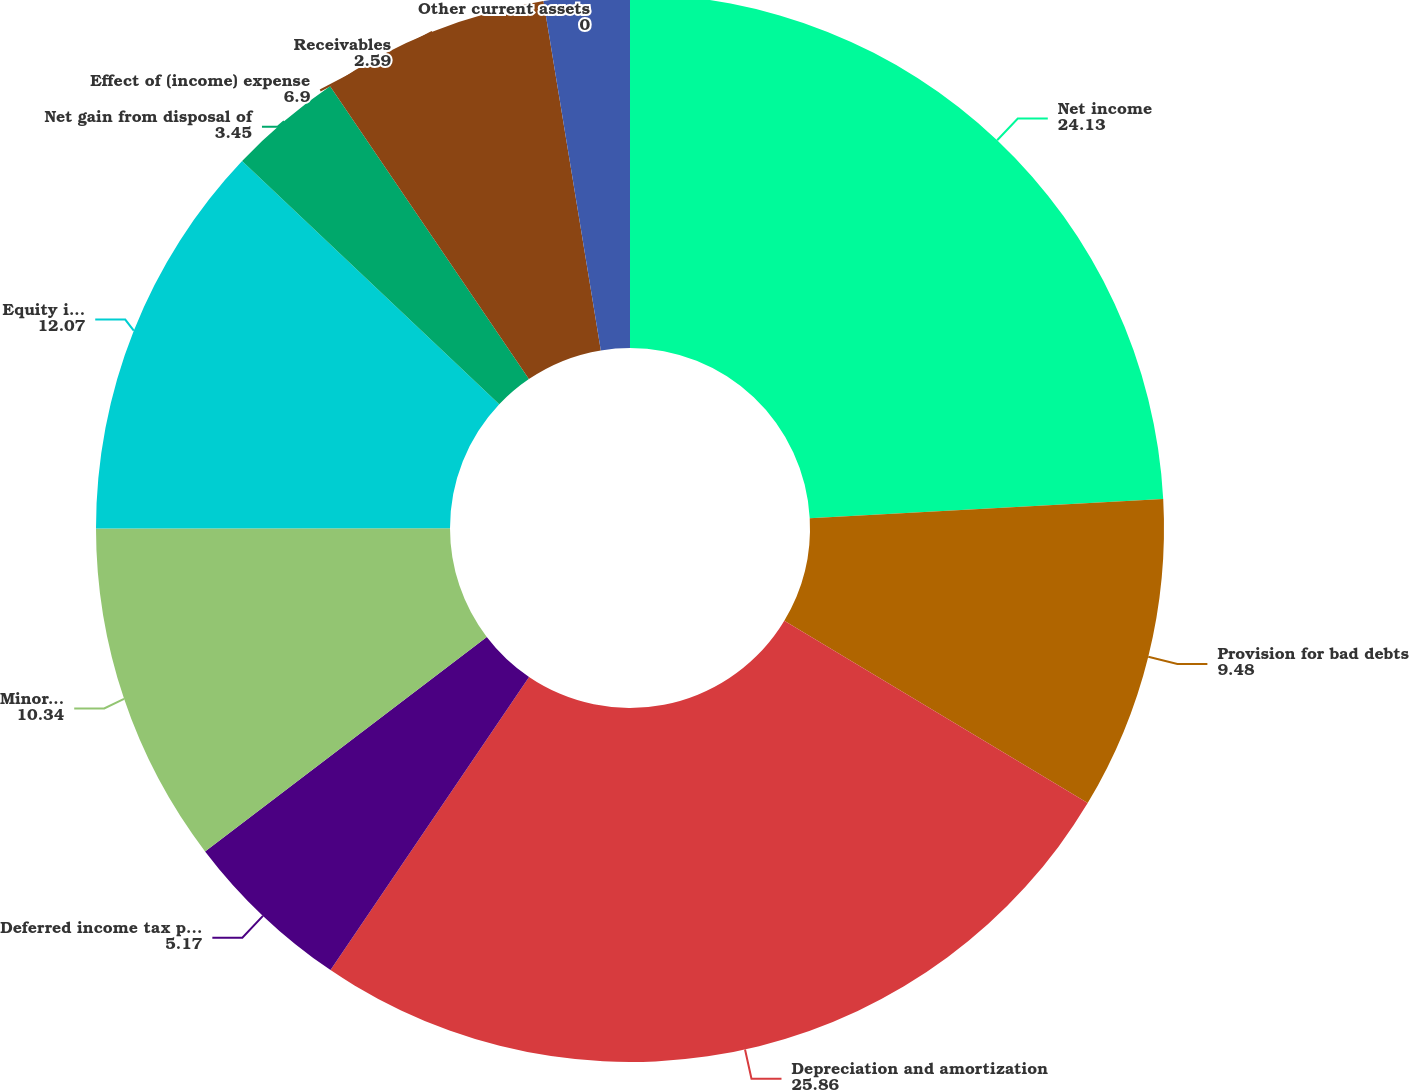Convert chart. <chart><loc_0><loc_0><loc_500><loc_500><pie_chart><fcel>Net income<fcel>Provision for bad debts<fcel>Depreciation and amortization<fcel>Deferred income tax provision<fcel>Minority interest<fcel>Equity in net losses of<fcel>Net gain from disposal of<fcel>Effect of (income) expense<fcel>Receivables<fcel>Other current assets<nl><fcel>24.13%<fcel>9.48%<fcel>25.86%<fcel>5.17%<fcel>10.34%<fcel>12.07%<fcel>3.45%<fcel>6.9%<fcel>2.59%<fcel>0.0%<nl></chart> 